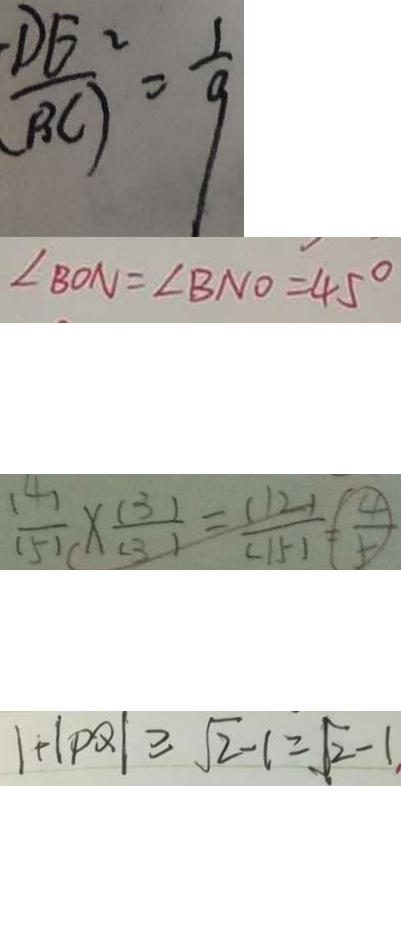Convert formula to latex. <formula><loc_0><loc_0><loc_500><loc_500>\frac { D E ^ { 2 } } { B C ) } = \frac { 1 } { 9 } 
 \angle B O N = \angle B N O = 4 5 ^ { \circ } 
 \frac { ( 4 ) } { ( 5 ) } \times \frac { ( 3 ) } { ( 3 ) } = \frac { ( 1 2 ) } { ( 1 5 ) } = \frac { 4 } { 5 } 
 1 + \vert P Q \vert \geq \sqrt { 2 } - 1 = \sqrt { 2 } - 1 .</formula> 